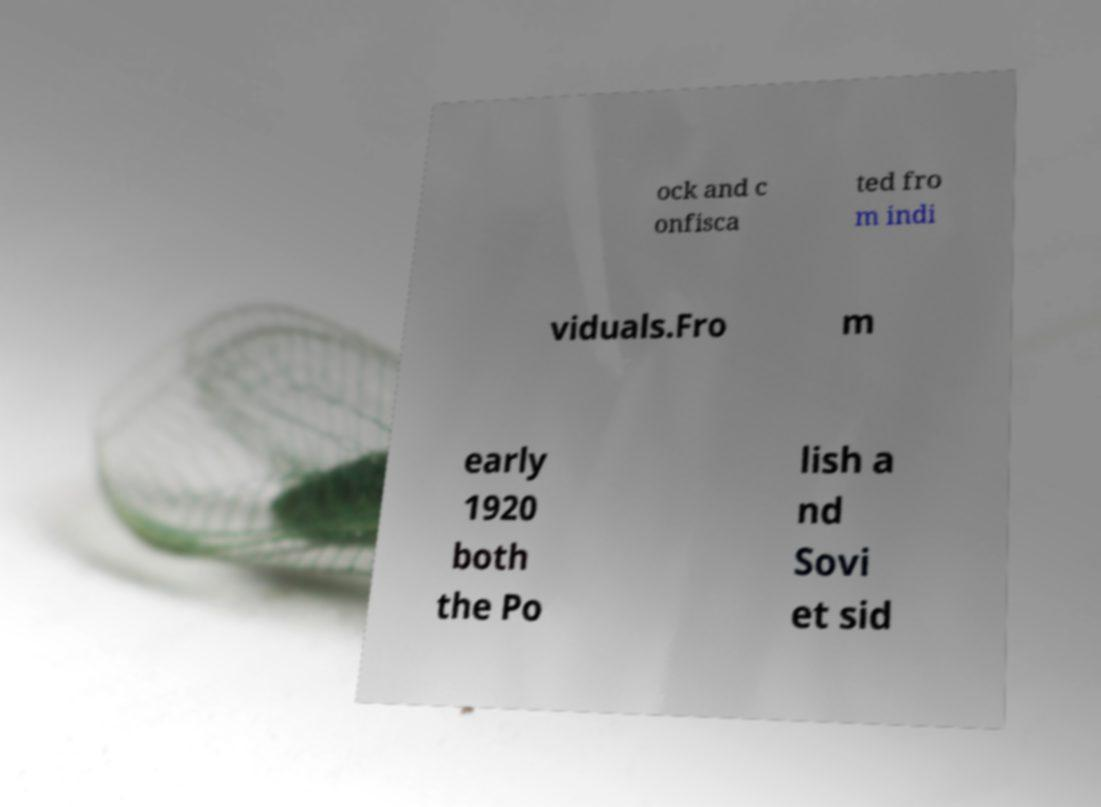I need the written content from this picture converted into text. Can you do that? ock and c onfisca ted fro m indi viduals.Fro m early 1920 both the Po lish a nd Sovi et sid 